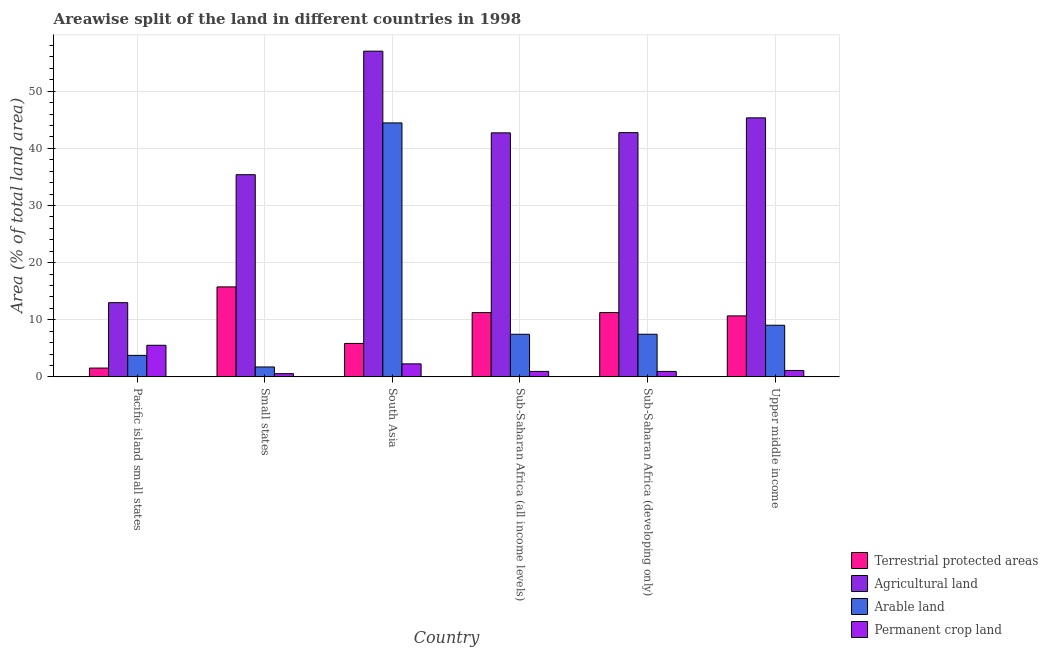How many different coloured bars are there?
Ensure brevity in your answer.  4. Are the number of bars per tick equal to the number of legend labels?
Your answer should be compact. Yes. Are the number of bars on each tick of the X-axis equal?
Your answer should be very brief. Yes. What is the label of the 1st group of bars from the left?
Make the answer very short. Pacific island small states. In how many cases, is the number of bars for a given country not equal to the number of legend labels?
Make the answer very short. 0. What is the percentage of land under terrestrial protection in Small states?
Your response must be concise. 15.75. Across all countries, what is the maximum percentage of area under agricultural land?
Keep it short and to the point. 57. Across all countries, what is the minimum percentage of area under permanent crop land?
Your response must be concise. 0.56. In which country was the percentage of land under terrestrial protection maximum?
Offer a very short reply. Small states. In which country was the percentage of area under arable land minimum?
Offer a very short reply. Small states. What is the total percentage of area under arable land in the graph?
Your answer should be compact. 73.89. What is the difference between the percentage of land under terrestrial protection in Pacific island small states and that in Sub-Saharan Africa (developing only)?
Provide a succinct answer. -9.71. What is the difference between the percentage of area under arable land in Sub-Saharan Africa (all income levels) and the percentage of area under agricultural land in Pacific island small states?
Provide a short and direct response. -5.53. What is the average percentage of area under permanent crop land per country?
Your response must be concise. 1.9. What is the difference between the percentage of area under arable land and percentage of land under terrestrial protection in Small states?
Ensure brevity in your answer.  -14.01. In how many countries, is the percentage of area under arable land greater than 2 %?
Provide a short and direct response. 5. What is the ratio of the percentage of land under terrestrial protection in Pacific island small states to that in Small states?
Provide a succinct answer. 0.1. Is the percentage of land under terrestrial protection in South Asia less than that in Upper middle income?
Offer a very short reply. Yes. Is the difference between the percentage of area under arable land in South Asia and Sub-Saharan Africa (developing only) greater than the difference between the percentage of land under terrestrial protection in South Asia and Sub-Saharan Africa (developing only)?
Make the answer very short. Yes. What is the difference between the highest and the second highest percentage of land under terrestrial protection?
Provide a short and direct response. 4.49. What is the difference between the highest and the lowest percentage of area under permanent crop land?
Make the answer very short. 4.97. In how many countries, is the percentage of area under arable land greater than the average percentage of area under arable land taken over all countries?
Your answer should be very brief. 1. What does the 4th bar from the left in South Asia represents?
Your answer should be compact. Permanent crop land. What does the 4th bar from the right in Sub-Saharan Africa (all income levels) represents?
Provide a short and direct response. Terrestrial protected areas. How many bars are there?
Give a very brief answer. 24. What is the difference between two consecutive major ticks on the Y-axis?
Give a very brief answer. 10. Are the values on the major ticks of Y-axis written in scientific E-notation?
Offer a very short reply. No. Where does the legend appear in the graph?
Keep it short and to the point. Bottom right. How many legend labels are there?
Your answer should be compact. 4. What is the title of the graph?
Keep it short and to the point. Areawise split of the land in different countries in 1998. Does "Primary education" appear as one of the legend labels in the graph?
Your response must be concise. No. What is the label or title of the X-axis?
Your response must be concise. Country. What is the label or title of the Y-axis?
Keep it short and to the point. Area (% of total land area). What is the Area (% of total land area) in Terrestrial protected areas in Pacific island small states?
Give a very brief answer. 1.54. What is the Area (% of total land area) of Agricultural land in Pacific island small states?
Ensure brevity in your answer.  12.99. What is the Area (% of total land area) in Arable land in Pacific island small states?
Make the answer very short. 3.76. What is the Area (% of total land area) of Permanent crop land in Pacific island small states?
Keep it short and to the point. 5.53. What is the Area (% of total land area) in Terrestrial protected areas in Small states?
Ensure brevity in your answer.  15.75. What is the Area (% of total land area) of Agricultural land in Small states?
Provide a short and direct response. 35.38. What is the Area (% of total land area) of Arable land in Small states?
Your answer should be very brief. 1.73. What is the Area (% of total land area) of Permanent crop land in Small states?
Ensure brevity in your answer.  0.56. What is the Area (% of total land area) in Terrestrial protected areas in South Asia?
Provide a short and direct response. 5.85. What is the Area (% of total land area) of Agricultural land in South Asia?
Keep it short and to the point. 57. What is the Area (% of total land area) of Arable land in South Asia?
Keep it short and to the point. 44.45. What is the Area (% of total land area) of Permanent crop land in South Asia?
Your answer should be compact. 2.28. What is the Area (% of total land area) in Terrestrial protected areas in Sub-Saharan Africa (all income levels)?
Offer a very short reply. 11.25. What is the Area (% of total land area) in Agricultural land in Sub-Saharan Africa (all income levels)?
Your response must be concise. 42.71. What is the Area (% of total land area) in Arable land in Sub-Saharan Africa (all income levels)?
Your response must be concise. 7.46. What is the Area (% of total land area) of Permanent crop land in Sub-Saharan Africa (all income levels)?
Ensure brevity in your answer.  0.95. What is the Area (% of total land area) in Terrestrial protected areas in Sub-Saharan Africa (developing only)?
Provide a short and direct response. 11.26. What is the Area (% of total land area) of Agricultural land in Sub-Saharan Africa (developing only)?
Provide a succinct answer. 42.74. What is the Area (% of total land area) in Arable land in Sub-Saharan Africa (developing only)?
Your answer should be compact. 7.46. What is the Area (% of total land area) of Permanent crop land in Sub-Saharan Africa (developing only)?
Provide a succinct answer. 0.95. What is the Area (% of total land area) in Terrestrial protected areas in Upper middle income?
Give a very brief answer. 10.67. What is the Area (% of total land area) in Agricultural land in Upper middle income?
Your answer should be very brief. 45.33. What is the Area (% of total land area) in Arable land in Upper middle income?
Provide a succinct answer. 9.03. What is the Area (% of total land area) in Permanent crop land in Upper middle income?
Offer a terse response. 1.12. Across all countries, what is the maximum Area (% of total land area) in Terrestrial protected areas?
Offer a very short reply. 15.75. Across all countries, what is the maximum Area (% of total land area) in Agricultural land?
Your answer should be very brief. 57. Across all countries, what is the maximum Area (% of total land area) in Arable land?
Provide a succinct answer. 44.45. Across all countries, what is the maximum Area (% of total land area) in Permanent crop land?
Provide a short and direct response. 5.53. Across all countries, what is the minimum Area (% of total land area) of Terrestrial protected areas?
Give a very brief answer. 1.54. Across all countries, what is the minimum Area (% of total land area) of Agricultural land?
Ensure brevity in your answer.  12.99. Across all countries, what is the minimum Area (% of total land area) of Arable land?
Your answer should be very brief. 1.73. Across all countries, what is the minimum Area (% of total land area) in Permanent crop land?
Provide a succinct answer. 0.56. What is the total Area (% of total land area) of Terrestrial protected areas in the graph?
Provide a short and direct response. 56.32. What is the total Area (% of total land area) of Agricultural land in the graph?
Keep it short and to the point. 236.16. What is the total Area (% of total land area) in Arable land in the graph?
Your response must be concise. 73.89. What is the total Area (% of total land area) in Permanent crop land in the graph?
Your response must be concise. 11.4. What is the difference between the Area (% of total land area) in Terrestrial protected areas in Pacific island small states and that in Small states?
Provide a short and direct response. -14.21. What is the difference between the Area (% of total land area) in Agricultural land in Pacific island small states and that in Small states?
Make the answer very short. -22.4. What is the difference between the Area (% of total land area) of Arable land in Pacific island small states and that in Small states?
Your response must be concise. 2.03. What is the difference between the Area (% of total land area) in Permanent crop land in Pacific island small states and that in Small states?
Ensure brevity in your answer.  4.97. What is the difference between the Area (% of total land area) in Terrestrial protected areas in Pacific island small states and that in South Asia?
Your answer should be very brief. -4.31. What is the difference between the Area (% of total land area) of Agricultural land in Pacific island small states and that in South Asia?
Make the answer very short. -44.02. What is the difference between the Area (% of total land area) of Arable land in Pacific island small states and that in South Asia?
Offer a terse response. -40.68. What is the difference between the Area (% of total land area) of Permanent crop land in Pacific island small states and that in South Asia?
Your answer should be compact. 3.26. What is the difference between the Area (% of total land area) of Terrestrial protected areas in Pacific island small states and that in Sub-Saharan Africa (all income levels)?
Make the answer very short. -9.71. What is the difference between the Area (% of total land area) of Agricultural land in Pacific island small states and that in Sub-Saharan Africa (all income levels)?
Ensure brevity in your answer.  -29.72. What is the difference between the Area (% of total land area) in Arable land in Pacific island small states and that in Sub-Saharan Africa (all income levels)?
Keep it short and to the point. -3.69. What is the difference between the Area (% of total land area) of Permanent crop land in Pacific island small states and that in Sub-Saharan Africa (all income levels)?
Provide a short and direct response. 4.58. What is the difference between the Area (% of total land area) in Terrestrial protected areas in Pacific island small states and that in Sub-Saharan Africa (developing only)?
Provide a succinct answer. -9.71. What is the difference between the Area (% of total land area) in Agricultural land in Pacific island small states and that in Sub-Saharan Africa (developing only)?
Your response must be concise. -29.76. What is the difference between the Area (% of total land area) in Arable land in Pacific island small states and that in Sub-Saharan Africa (developing only)?
Your response must be concise. -3.69. What is the difference between the Area (% of total land area) of Permanent crop land in Pacific island small states and that in Sub-Saharan Africa (developing only)?
Ensure brevity in your answer.  4.58. What is the difference between the Area (% of total land area) in Terrestrial protected areas in Pacific island small states and that in Upper middle income?
Your response must be concise. -9.13. What is the difference between the Area (% of total land area) of Agricultural land in Pacific island small states and that in Upper middle income?
Make the answer very short. -32.34. What is the difference between the Area (% of total land area) in Arable land in Pacific island small states and that in Upper middle income?
Ensure brevity in your answer.  -5.27. What is the difference between the Area (% of total land area) of Permanent crop land in Pacific island small states and that in Upper middle income?
Your answer should be very brief. 4.41. What is the difference between the Area (% of total land area) of Terrestrial protected areas in Small states and that in South Asia?
Your response must be concise. 9.9. What is the difference between the Area (% of total land area) of Agricultural land in Small states and that in South Asia?
Provide a short and direct response. -21.62. What is the difference between the Area (% of total land area) in Arable land in Small states and that in South Asia?
Make the answer very short. -42.71. What is the difference between the Area (% of total land area) of Permanent crop land in Small states and that in South Asia?
Your answer should be compact. -1.72. What is the difference between the Area (% of total land area) in Terrestrial protected areas in Small states and that in Sub-Saharan Africa (all income levels)?
Offer a terse response. 4.5. What is the difference between the Area (% of total land area) of Agricultural land in Small states and that in Sub-Saharan Africa (all income levels)?
Ensure brevity in your answer.  -7.32. What is the difference between the Area (% of total land area) in Arable land in Small states and that in Sub-Saharan Africa (all income levels)?
Give a very brief answer. -5.72. What is the difference between the Area (% of total land area) in Permanent crop land in Small states and that in Sub-Saharan Africa (all income levels)?
Give a very brief answer. -0.4. What is the difference between the Area (% of total land area) in Terrestrial protected areas in Small states and that in Sub-Saharan Africa (developing only)?
Your answer should be compact. 4.49. What is the difference between the Area (% of total land area) in Agricultural land in Small states and that in Sub-Saharan Africa (developing only)?
Offer a terse response. -7.36. What is the difference between the Area (% of total land area) in Arable land in Small states and that in Sub-Saharan Africa (developing only)?
Provide a succinct answer. -5.73. What is the difference between the Area (% of total land area) in Permanent crop land in Small states and that in Sub-Saharan Africa (developing only)?
Provide a short and direct response. -0.39. What is the difference between the Area (% of total land area) of Terrestrial protected areas in Small states and that in Upper middle income?
Ensure brevity in your answer.  5.08. What is the difference between the Area (% of total land area) of Agricultural land in Small states and that in Upper middle income?
Provide a short and direct response. -9.95. What is the difference between the Area (% of total land area) of Arable land in Small states and that in Upper middle income?
Your answer should be compact. -7.3. What is the difference between the Area (% of total land area) of Permanent crop land in Small states and that in Upper middle income?
Your answer should be very brief. -0.56. What is the difference between the Area (% of total land area) of Agricultural land in South Asia and that in Sub-Saharan Africa (all income levels)?
Give a very brief answer. 14.3. What is the difference between the Area (% of total land area) of Arable land in South Asia and that in Sub-Saharan Africa (all income levels)?
Provide a short and direct response. 36.99. What is the difference between the Area (% of total land area) of Permanent crop land in South Asia and that in Sub-Saharan Africa (all income levels)?
Keep it short and to the point. 1.32. What is the difference between the Area (% of total land area) in Terrestrial protected areas in South Asia and that in Sub-Saharan Africa (developing only)?
Ensure brevity in your answer.  -5.4. What is the difference between the Area (% of total land area) in Agricultural land in South Asia and that in Sub-Saharan Africa (developing only)?
Ensure brevity in your answer.  14.26. What is the difference between the Area (% of total land area) of Arable land in South Asia and that in Sub-Saharan Africa (developing only)?
Your answer should be compact. 36.99. What is the difference between the Area (% of total land area) of Permanent crop land in South Asia and that in Sub-Saharan Africa (developing only)?
Ensure brevity in your answer.  1.32. What is the difference between the Area (% of total land area) of Terrestrial protected areas in South Asia and that in Upper middle income?
Ensure brevity in your answer.  -4.82. What is the difference between the Area (% of total land area) in Agricultural land in South Asia and that in Upper middle income?
Your response must be concise. 11.67. What is the difference between the Area (% of total land area) of Arable land in South Asia and that in Upper middle income?
Keep it short and to the point. 35.41. What is the difference between the Area (% of total land area) of Permanent crop land in South Asia and that in Upper middle income?
Give a very brief answer. 1.15. What is the difference between the Area (% of total land area) of Terrestrial protected areas in Sub-Saharan Africa (all income levels) and that in Sub-Saharan Africa (developing only)?
Give a very brief answer. -0. What is the difference between the Area (% of total land area) of Agricultural land in Sub-Saharan Africa (all income levels) and that in Sub-Saharan Africa (developing only)?
Your answer should be very brief. -0.04. What is the difference between the Area (% of total land area) in Arable land in Sub-Saharan Africa (all income levels) and that in Sub-Saharan Africa (developing only)?
Offer a very short reply. -0. What is the difference between the Area (% of total land area) of Permanent crop land in Sub-Saharan Africa (all income levels) and that in Sub-Saharan Africa (developing only)?
Your answer should be very brief. 0. What is the difference between the Area (% of total land area) in Terrestrial protected areas in Sub-Saharan Africa (all income levels) and that in Upper middle income?
Keep it short and to the point. 0.58. What is the difference between the Area (% of total land area) in Agricultural land in Sub-Saharan Africa (all income levels) and that in Upper middle income?
Keep it short and to the point. -2.62. What is the difference between the Area (% of total land area) of Arable land in Sub-Saharan Africa (all income levels) and that in Upper middle income?
Offer a very short reply. -1.58. What is the difference between the Area (% of total land area) of Permanent crop land in Sub-Saharan Africa (all income levels) and that in Upper middle income?
Give a very brief answer. -0.17. What is the difference between the Area (% of total land area) in Terrestrial protected areas in Sub-Saharan Africa (developing only) and that in Upper middle income?
Make the answer very short. 0.59. What is the difference between the Area (% of total land area) in Agricultural land in Sub-Saharan Africa (developing only) and that in Upper middle income?
Your answer should be very brief. -2.59. What is the difference between the Area (% of total land area) in Arable land in Sub-Saharan Africa (developing only) and that in Upper middle income?
Make the answer very short. -1.58. What is the difference between the Area (% of total land area) in Permanent crop land in Sub-Saharan Africa (developing only) and that in Upper middle income?
Offer a terse response. -0.17. What is the difference between the Area (% of total land area) of Terrestrial protected areas in Pacific island small states and the Area (% of total land area) of Agricultural land in Small states?
Your answer should be compact. -33.84. What is the difference between the Area (% of total land area) in Terrestrial protected areas in Pacific island small states and the Area (% of total land area) in Arable land in Small states?
Keep it short and to the point. -0.19. What is the difference between the Area (% of total land area) of Terrestrial protected areas in Pacific island small states and the Area (% of total land area) of Permanent crop land in Small states?
Provide a succinct answer. 0.98. What is the difference between the Area (% of total land area) in Agricultural land in Pacific island small states and the Area (% of total land area) in Arable land in Small states?
Offer a terse response. 11.25. What is the difference between the Area (% of total land area) of Agricultural land in Pacific island small states and the Area (% of total land area) of Permanent crop land in Small states?
Your answer should be very brief. 12.43. What is the difference between the Area (% of total land area) of Arable land in Pacific island small states and the Area (% of total land area) of Permanent crop land in Small states?
Your answer should be compact. 3.2. What is the difference between the Area (% of total land area) in Terrestrial protected areas in Pacific island small states and the Area (% of total land area) in Agricultural land in South Asia?
Ensure brevity in your answer.  -55.46. What is the difference between the Area (% of total land area) in Terrestrial protected areas in Pacific island small states and the Area (% of total land area) in Arable land in South Asia?
Give a very brief answer. -42.9. What is the difference between the Area (% of total land area) of Terrestrial protected areas in Pacific island small states and the Area (% of total land area) of Permanent crop land in South Asia?
Keep it short and to the point. -0.73. What is the difference between the Area (% of total land area) in Agricultural land in Pacific island small states and the Area (% of total land area) in Arable land in South Asia?
Your answer should be very brief. -31.46. What is the difference between the Area (% of total land area) in Agricultural land in Pacific island small states and the Area (% of total land area) in Permanent crop land in South Asia?
Ensure brevity in your answer.  10.71. What is the difference between the Area (% of total land area) in Arable land in Pacific island small states and the Area (% of total land area) in Permanent crop land in South Asia?
Keep it short and to the point. 1.49. What is the difference between the Area (% of total land area) of Terrestrial protected areas in Pacific island small states and the Area (% of total land area) of Agricultural land in Sub-Saharan Africa (all income levels)?
Your answer should be very brief. -41.17. What is the difference between the Area (% of total land area) in Terrestrial protected areas in Pacific island small states and the Area (% of total land area) in Arable land in Sub-Saharan Africa (all income levels)?
Make the answer very short. -5.91. What is the difference between the Area (% of total land area) of Terrestrial protected areas in Pacific island small states and the Area (% of total land area) of Permanent crop land in Sub-Saharan Africa (all income levels)?
Your response must be concise. 0.59. What is the difference between the Area (% of total land area) of Agricultural land in Pacific island small states and the Area (% of total land area) of Arable land in Sub-Saharan Africa (all income levels)?
Provide a short and direct response. 5.53. What is the difference between the Area (% of total land area) of Agricultural land in Pacific island small states and the Area (% of total land area) of Permanent crop land in Sub-Saharan Africa (all income levels)?
Your answer should be very brief. 12.03. What is the difference between the Area (% of total land area) of Arable land in Pacific island small states and the Area (% of total land area) of Permanent crop land in Sub-Saharan Africa (all income levels)?
Ensure brevity in your answer.  2.81. What is the difference between the Area (% of total land area) in Terrestrial protected areas in Pacific island small states and the Area (% of total land area) in Agricultural land in Sub-Saharan Africa (developing only)?
Offer a very short reply. -41.2. What is the difference between the Area (% of total land area) of Terrestrial protected areas in Pacific island small states and the Area (% of total land area) of Arable land in Sub-Saharan Africa (developing only)?
Offer a very short reply. -5.92. What is the difference between the Area (% of total land area) in Terrestrial protected areas in Pacific island small states and the Area (% of total land area) in Permanent crop land in Sub-Saharan Africa (developing only)?
Provide a succinct answer. 0.59. What is the difference between the Area (% of total land area) in Agricultural land in Pacific island small states and the Area (% of total land area) in Arable land in Sub-Saharan Africa (developing only)?
Keep it short and to the point. 5.53. What is the difference between the Area (% of total land area) of Agricultural land in Pacific island small states and the Area (% of total land area) of Permanent crop land in Sub-Saharan Africa (developing only)?
Your response must be concise. 12.04. What is the difference between the Area (% of total land area) of Arable land in Pacific island small states and the Area (% of total land area) of Permanent crop land in Sub-Saharan Africa (developing only)?
Give a very brief answer. 2.81. What is the difference between the Area (% of total land area) of Terrestrial protected areas in Pacific island small states and the Area (% of total land area) of Agricultural land in Upper middle income?
Ensure brevity in your answer.  -43.79. What is the difference between the Area (% of total land area) of Terrestrial protected areas in Pacific island small states and the Area (% of total land area) of Arable land in Upper middle income?
Your response must be concise. -7.49. What is the difference between the Area (% of total land area) in Terrestrial protected areas in Pacific island small states and the Area (% of total land area) in Permanent crop land in Upper middle income?
Keep it short and to the point. 0.42. What is the difference between the Area (% of total land area) of Agricultural land in Pacific island small states and the Area (% of total land area) of Arable land in Upper middle income?
Offer a very short reply. 3.95. What is the difference between the Area (% of total land area) of Agricultural land in Pacific island small states and the Area (% of total land area) of Permanent crop land in Upper middle income?
Your answer should be compact. 11.86. What is the difference between the Area (% of total land area) in Arable land in Pacific island small states and the Area (% of total land area) in Permanent crop land in Upper middle income?
Offer a terse response. 2.64. What is the difference between the Area (% of total land area) of Terrestrial protected areas in Small states and the Area (% of total land area) of Agricultural land in South Asia?
Provide a succinct answer. -41.26. What is the difference between the Area (% of total land area) of Terrestrial protected areas in Small states and the Area (% of total land area) of Arable land in South Asia?
Ensure brevity in your answer.  -28.7. What is the difference between the Area (% of total land area) in Terrestrial protected areas in Small states and the Area (% of total land area) in Permanent crop land in South Asia?
Make the answer very short. 13.47. What is the difference between the Area (% of total land area) of Agricultural land in Small states and the Area (% of total land area) of Arable land in South Asia?
Offer a terse response. -9.06. What is the difference between the Area (% of total land area) in Agricultural land in Small states and the Area (% of total land area) in Permanent crop land in South Asia?
Ensure brevity in your answer.  33.11. What is the difference between the Area (% of total land area) of Arable land in Small states and the Area (% of total land area) of Permanent crop land in South Asia?
Your answer should be compact. -0.54. What is the difference between the Area (% of total land area) in Terrestrial protected areas in Small states and the Area (% of total land area) in Agricultural land in Sub-Saharan Africa (all income levels)?
Provide a short and direct response. -26.96. What is the difference between the Area (% of total land area) of Terrestrial protected areas in Small states and the Area (% of total land area) of Arable land in Sub-Saharan Africa (all income levels)?
Offer a terse response. 8.29. What is the difference between the Area (% of total land area) of Terrestrial protected areas in Small states and the Area (% of total land area) of Permanent crop land in Sub-Saharan Africa (all income levels)?
Ensure brevity in your answer.  14.79. What is the difference between the Area (% of total land area) of Agricultural land in Small states and the Area (% of total land area) of Arable land in Sub-Saharan Africa (all income levels)?
Provide a short and direct response. 27.93. What is the difference between the Area (% of total land area) of Agricultural land in Small states and the Area (% of total land area) of Permanent crop land in Sub-Saharan Africa (all income levels)?
Your answer should be compact. 34.43. What is the difference between the Area (% of total land area) in Arable land in Small states and the Area (% of total land area) in Permanent crop land in Sub-Saharan Africa (all income levels)?
Your answer should be compact. 0.78. What is the difference between the Area (% of total land area) of Terrestrial protected areas in Small states and the Area (% of total land area) of Agricultural land in Sub-Saharan Africa (developing only)?
Give a very brief answer. -27. What is the difference between the Area (% of total land area) of Terrestrial protected areas in Small states and the Area (% of total land area) of Arable land in Sub-Saharan Africa (developing only)?
Offer a very short reply. 8.29. What is the difference between the Area (% of total land area) in Terrestrial protected areas in Small states and the Area (% of total land area) in Permanent crop land in Sub-Saharan Africa (developing only)?
Provide a short and direct response. 14.8. What is the difference between the Area (% of total land area) of Agricultural land in Small states and the Area (% of total land area) of Arable land in Sub-Saharan Africa (developing only)?
Offer a very short reply. 27.92. What is the difference between the Area (% of total land area) of Agricultural land in Small states and the Area (% of total land area) of Permanent crop land in Sub-Saharan Africa (developing only)?
Provide a short and direct response. 34.43. What is the difference between the Area (% of total land area) of Arable land in Small states and the Area (% of total land area) of Permanent crop land in Sub-Saharan Africa (developing only)?
Offer a very short reply. 0.78. What is the difference between the Area (% of total land area) of Terrestrial protected areas in Small states and the Area (% of total land area) of Agricultural land in Upper middle income?
Offer a very short reply. -29.58. What is the difference between the Area (% of total land area) of Terrestrial protected areas in Small states and the Area (% of total land area) of Arable land in Upper middle income?
Your answer should be very brief. 6.71. What is the difference between the Area (% of total land area) of Terrestrial protected areas in Small states and the Area (% of total land area) of Permanent crop land in Upper middle income?
Offer a very short reply. 14.62. What is the difference between the Area (% of total land area) of Agricultural land in Small states and the Area (% of total land area) of Arable land in Upper middle income?
Provide a short and direct response. 26.35. What is the difference between the Area (% of total land area) of Agricultural land in Small states and the Area (% of total land area) of Permanent crop land in Upper middle income?
Ensure brevity in your answer.  34.26. What is the difference between the Area (% of total land area) of Arable land in Small states and the Area (% of total land area) of Permanent crop land in Upper middle income?
Make the answer very short. 0.61. What is the difference between the Area (% of total land area) in Terrestrial protected areas in South Asia and the Area (% of total land area) in Agricultural land in Sub-Saharan Africa (all income levels)?
Your response must be concise. -36.85. What is the difference between the Area (% of total land area) of Terrestrial protected areas in South Asia and the Area (% of total land area) of Arable land in Sub-Saharan Africa (all income levels)?
Provide a succinct answer. -1.6. What is the difference between the Area (% of total land area) in Terrestrial protected areas in South Asia and the Area (% of total land area) in Permanent crop land in Sub-Saharan Africa (all income levels)?
Offer a very short reply. 4.9. What is the difference between the Area (% of total land area) of Agricultural land in South Asia and the Area (% of total land area) of Arable land in Sub-Saharan Africa (all income levels)?
Your response must be concise. 49.55. What is the difference between the Area (% of total land area) in Agricultural land in South Asia and the Area (% of total land area) in Permanent crop land in Sub-Saharan Africa (all income levels)?
Your answer should be very brief. 56.05. What is the difference between the Area (% of total land area) in Arable land in South Asia and the Area (% of total land area) in Permanent crop land in Sub-Saharan Africa (all income levels)?
Ensure brevity in your answer.  43.49. What is the difference between the Area (% of total land area) in Terrestrial protected areas in South Asia and the Area (% of total land area) in Agricultural land in Sub-Saharan Africa (developing only)?
Your response must be concise. -36.89. What is the difference between the Area (% of total land area) in Terrestrial protected areas in South Asia and the Area (% of total land area) in Arable land in Sub-Saharan Africa (developing only)?
Keep it short and to the point. -1.61. What is the difference between the Area (% of total land area) of Terrestrial protected areas in South Asia and the Area (% of total land area) of Permanent crop land in Sub-Saharan Africa (developing only)?
Your answer should be compact. 4.9. What is the difference between the Area (% of total land area) in Agricultural land in South Asia and the Area (% of total land area) in Arable land in Sub-Saharan Africa (developing only)?
Offer a very short reply. 49.54. What is the difference between the Area (% of total land area) in Agricultural land in South Asia and the Area (% of total land area) in Permanent crop land in Sub-Saharan Africa (developing only)?
Offer a very short reply. 56.05. What is the difference between the Area (% of total land area) of Arable land in South Asia and the Area (% of total land area) of Permanent crop land in Sub-Saharan Africa (developing only)?
Keep it short and to the point. 43.49. What is the difference between the Area (% of total land area) of Terrestrial protected areas in South Asia and the Area (% of total land area) of Agricultural land in Upper middle income?
Your response must be concise. -39.48. What is the difference between the Area (% of total land area) of Terrestrial protected areas in South Asia and the Area (% of total land area) of Arable land in Upper middle income?
Offer a very short reply. -3.18. What is the difference between the Area (% of total land area) in Terrestrial protected areas in South Asia and the Area (% of total land area) in Permanent crop land in Upper middle income?
Give a very brief answer. 4.73. What is the difference between the Area (% of total land area) of Agricultural land in South Asia and the Area (% of total land area) of Arable land in Upper middle income?
Provide a short and direct response. 47.97. What is the difference between the Area (% of total land area) in Agricultural land in South Asia and the Area (% of total land area) in Permanent crop land in Upper middle income?
Give a very brief answer. 55.88. What is the difference between the Area (% of total land area) of Arable land in South Asia and the Area (% of total land area) of Permanent crop land in Upper middle income?
Keep it short and to the point. 43.32. What is the difference between the Area (% of total land area) of Terrestrial protected areas in Sub-Saharan Africa (all income levels) and the Area (% of total land area) of Agricultural land in Sub-Saharan Africa (developing only)?
Offer a terse response. -31.49. What is the difference between the Area (% of total land area) in Terrestrial protected areas in Sub-Saharan Africa (all income levels) and the Area (% of total land area) in Arable land in Sub-Saharan Africa (developing only)?
Make the answer very short. 3.79. What is the difference between the Area (% of total land area) of Terrestrial protected areas in Sub-Saharan Africa (all income levels) and the Area (% of total land area) of Permanent crop land in Sub-Saharan Africa (developing only)?
Your answer should be compact. 10.3. What is the difference between the Area (% of total land area) in Agricultural land in Sub-Saharan Africa (all income levels) and the Area (% of total land area) in Arable land in Sub-Saharan Africa (developing only)?
Provide a succinct answer. 35.25. What is the difference between the Area (% of total land area) in Agricultural land in Sub-Saharan Africa (all income levels) and the Area (% of total land area) in Permanent crop land in Sub-Saharan Africa (developing only)?
Offer a very short reply. 41.76. What is the difference between the Area (% of total land area) of Arable land in Sub-Saharan Africa (all income levels) and the Area (% of total land area) of Permanent crop land in Sub-Saharan Africa (developing only)?
Your response must be concise. 6.5. What is the difference between the Area (% of total land area) in Terrestrial protected areas in Sub-Saharan Africa (all income levels) and the Area (% of total land area) in Agricultural land in Upper middle income?
Provide a succinct answer. -34.08. What is the difference between the Area (% of total land area) in Terrestrial protected areas in Sub-Saharan Africa (all income levels) and the Area (% of total land area) in Arable land in Upper middle income?
Your answer should be very brief. 2.22. What is the difference between the Area (% of total land area) of Terrestrial protected areas in Sub-Saharan Africa (all income levels) and the Area (% of total land area) of Permanent crop land in Upper middle income?
Give a very brief answer. 10.13. What is the difference between the Area (% of total land area) in Agricultural land in Sub-Saharan Africa (all income levels) and the Area (% of total land area) in Arable land in Upper middle income?
Your answer should be very brief. 33.67. What is the difference between the Area (% of total land area) of Agricultural land in Sub-Saharan Africa (all income levels) and the Area (% of total land area) of Permanent crop land in Upper middle income?
Give a very brief answer. 41.58. What is the difference between the Area (% of total land area) of Arable land in Sub-Saharan Africa (all income levels) and the Area (% of total land area) of Permanent crop land in Upper middle income?
Your response must be concise. 6.33. What is the difference between the Area (% of total land area) in Terrestrial protected areas in Sub-Saharan Africa (developing only) and the Area (% of total land area) in Agricultural land in Upper middle income?
Offer a terse response. -34.07. What is the difference between the Area (% of total land area) of Terrestrial protected areas in Sub-Saharan Africa (developing only) and the Area (% of total land area) of Arable land in Upper middle income?
Your answer should be compact. 2.22. What is the difference between the Area (% of total land area) in Terrestrial protected areas in Sub-Saharan Africa (developing only) and the Area (% of total land area) in Permanent crop land in Upper middle income?
Offer a terse response. 10.13. What is the difference between the Area (% of total land area) in Agricultural land in Sub-Saharan Africa (developing only) and the Area (% of total land area) in Arable land in Upper middle income?
Offer a terse response. 33.71. What is the difference between the Area (% of total land area) of Agricultural land in Sub-Saharan Africa (developing only) and the Area (% of total land area) of Permanent crop land in Upper middle income?
Keep it short and to the point. 41.62. What is the difference between the Area (% of total land area) of Arable land in Sub-Saharan Africa (developing only) and the Area (% of total land area) of Permanent crop land in Upper middle income?
Your answer should be compact. 6.34. What is the average Area (% of total land area) in Terrestrial protected areas per country?
Keep it short and to the point. 9.39. What is the average Area (% of total land area) of Agricultural land per country?
Your response must be concise. 39.36. What is the average Area (% of total land area) of Arable land per country?
Provide a succinct answer. 12.32. What is the average Area (% of total land area) in Permanent crop land per country?
Your answer should be very brief. 1.9. What is the difference between the Area (% of total land area) of Terrestrial protected areas and Area (% of total land area) of Agricultural land in Pacific island small states?
Make the answer very short. -11.45. What is the difference between the Area (% of total land area) in Terrestrial protected areas and Area (% of total land area) in Arable land in Pacific island small states?
Offer a terse response. -2.22. What is the difference between the Area (% of total land area) of Terrestrial protected areas and Area (% of total land area) of Permanent crop land in Pacific island small states?
Offer a terse response. -3.99. What is the difference between the Area (% of total land area) of Agricultural land and Area (% of total land area) of Arable land in Pacific island small states?
Provide a succinct answer. 9.22. What is the difference between the Area (% of total land area) of Agricultural land and Area (% of total land area) of Permanent crop land in Pacific island small states?
Your answer should be compact. 7.46. What is the difference between the Area (% of total land area) of Arable land and Area (% of total land area) of Permanent crop land in Pacific island small states?
Your response must be concise. -1.77. What is the difference between the Area (% of total land area) of Terrestrial protected areas and Area (% of total land area) of Agricultural land in Small states?
Your answer should be compact. -19.64. What is the difference between the Area (% of total land area) of Terrestrial protected areas and Area (% of total land area) of Arable land in Small states?
Offer a very short reply. 14.01. What is the difference between the Area (% of total land area) of Terrestrial protected areas and Area (% of total land area) of Permanent crop land in Small states?
Offer a terse response. 15.19. What is the difference between the Area (% of total land area) of Agricultural land and Area (% of total land area) of Arable land in Small states?
Your answer should be very brief. 33.65. What is the difference between the Area (% of total land area) in Agricultural land and Area (% of total land area) in Permanent crop land in Small states?
Offer a terse response. 34.82. What is the difference between the Area (% of total land area) of Arable land and Area (% of total land area) of Permanent crop land in Small states?
Offer a terse response. 1.17. What is the difference between the Area (% of total land area) of Terrestrial protected areas and Area (% of total land area) of Agricultural land in South Asia?
Make the answer very short. -51.15. What is the difference between the Area (% of total land area) in Terrestrial protected areas and Area (% of total land area) in Arable land in South Asia?
Your answer should be compact. -38.59. What is the difference between the Area (% of total land area) in Terrestrial protected areas and Area (% of total land area) in Permanent crop land in South Asia?
Offer a terse response. 3.58. What is the difference between the Area (% of total land area) of Agricultural land and Area (% of total land area) of Arable land in South Asia?
Make the answer very short. 12.56. What is the difference between the Area (% of total land area) in Agricultural land and Area (% of total land area) in Permanent crop land in South Asia?
Give a very brief answer. 54.73. What is the difference between the Area (% of total land area) of Arable land and Area (% of total land area) of Permanent crop land in South Asia?
Your response must be concise. 42.17. What is the difference between the Area (% of total land area) in Terrestrial protected areas and Area (% of total land area) in Agricultural land in Sub-Saharan Africa (all income levels)?
Provide a succinct answer. -31.45. What is the difference between the Area (% of total land area) of Terrestrial protected areas and Area (% of total land area) of Arable land in Sub-Saharan Africa (all income levels)?
Offer a very short reply. 3.8. What is the difference between the Area (% of total land area) in Terrestrial protected areas and Area (% of total land area) in Permanent crop land in Sub-Saharan Africa (all income levels)?
Provide a succinct answer. 10.3. What is the difference between the Area (% of total land area) of Agricultural land and Area (% of total land area) of Arable land in Sub-Saharan Africa (all income levels)?
Your answer should be very brief. 35.25. What is the difference between the Area (% of total land area) in Agricultural land and Area (% of total land area) in Permanent crop land in Sub-Saharan Africa (all income levels)?
Offer a very short reply. 41.75. What is the difference between the Area (% of total land area) in Arable land and Area (% of total land area) in Permanent crop land in Sub-Saharan Africa (all income levels)?
Your answer should be very brief. 6.5. What is the difference between the Area (% of total land area) in Terrestrial protected areas and Area (% of total land area) in Agricultural land in Sub-Saharan Africa (developing only)?
Ensure brevity in your answer.  -31.49. What is the difference between the Area (% of total land area) of Terrestrial protected areas and Area (% of total land area) of Arable land in Sub-Saharan Africa (developing only)?
Make the answer very short. 3.8. What is the difference between the Area (% of total land area) of Terrestrial protected areas and Area (% of total land area) of Permanent crop land in Sub-Saharan Africa (developing only)?
Offer a terse response. 10.3. What is the difference between the Area (% of total land area) of Agricultural land and Area (% of total land area) of Arable land in Sub-Saharan Africa (developing only)?
Your response must be concise. 35.29. What is the difference between the Area (% of total land area) of Agricultural land and Area (% of total land area) of Permanent crop land in Sub-Saharan Africa (developing only)?
Ensure brevity in your answer.  41.79. What is the difference between the Area (% of total land area) of Arable land and Area (% of total land area) of Permanent crop land in Sub-Saharan Africa (developing only)?
Ensure brevity in your answer.  6.51. What is the difference between the Area (% of total land area) of Terrestrial protected areas and Area (% of total land area) of Agricultural land in Upper middle income?
Your answer should be very brief. -34.66. What is the difference between the Area (% of total land area) in Terrestrial protected areas and Area (% of total land area) in Arable land in Upper middle income?
Provide a succinct answer. 1.63. What is the difference between the Area (% of total land area) of Terrestrial protected areas and Area (% of total land area) of Permanent crop land in Upper middle income?
Your response must be concise. 9.55. What is the difference between the Area (% of total land area) in Agricultural land and Area (% of total land area) in Arable land in Upper middle income?
Keep it short and to the point. 36.3. What is the difference between the Area (% of total land area) of Agricultural land and Area (% of total land area) of Permanent crop land in Upper middle income?
Your answer should be very brief. 44.21. What is the difference between the Area (% of total land area) in Arable land and Area (% of total land area) in Permanent crop land in Upper middle income?
Your answer should be very brief. 7.91. What is the ratio of the Area (% of total land area) in Terrestrial protected areas in Pacific island small states to that in Small states?
Provide a short and direct response. 0.1. What is the ratio of the Area (% of total land area) of Agricultural land in Pacific island small states to that in Small states?
Provide a succinct answer. 0.37. What is the ratio of the Area (% of total land area) in Arable land in Pacific island small states to that in Small states?
Your response must be concise. 2.17. What is the ratio of the Area (% of total land area) in Permanent crop land in Pacific island small states to that in Small states?
Ensure brevity in your answer.  9.88. What is the ratio of the Area (% of total land area) in Terrestrial protected areas in Pacific island small states to that in South Asia?
Keep it short and to the point. 0.26. What is the ratio of the Area (% of total land area) of Agricultural land in Pacific island small states to that in South Asia?
Provide a short and direct response. 0.23. What is the ratio of the Area (% of total land area) in Arable land in Pacific island small states to that in South Asia?
Offer a terse response. 0.08. What is the ratio of the Area (% of total land area) of Permanent crop land in Pacific island small states to that in South Asia?
Ensure brevity in your answer.  2.43. What is the ratio of the Area (% of total land area) of Terrestrial protected areas in Pacific island small states to that in Sub-Saharan Africa (all income levels)?
Provide a succinct answer. 0.14. What is the ratio of the Area (% of total land area) in Agricultural land in Pacific island small states to that in Sub-Saharan Africa (all income levels)?
Ensure brevity in your answer.  0.3. What is the ratio of the Area (% of total land area) of Arable land in Pacific island small states to that in Sub-Saharan Africa (all income levels)?
Give a very brief answer. 0.5. What is the ratio of the Area (% of total land area) of Permanent crop land in Pacific island small states to that in Sub-Saharan Africa (all income levels)?
Your answer should be very brief. 5.79. What is the ratio of the Area (% of total land area) of Terrestrial protected areas in Pacific island small states to that in Sub-Saharan Africa (developing only)?
Provide a succinct answer. 0.14. What is the ratio of the Area (% of total land area) of Agricultural land in Pacific island small states to that in Sub-Saharan Africa (developing only)?
Your answer should be very brief. 0.3. What is the ratio of the Area (% of total land area) in Arable land in Pacific island small states to that in Sub-Saharan Africa (developing only)?
Your answer should be very brief. 0.5. What is the ratio of the Area (% of total land area) of Permanent crop land in Pacific island small states to that in Sub-Saharan Africa (developing only)?
Offer a very short reply. 5.81. What is the ratio of the Area (% of total land area) in Terrestrial protected areas in Pacific island small states to that in Upper middle income?
Your answer should be very brief. 0.14. What is the ratio of the Area (% of total land area) of Agricultural land in Pacific island small states to that in Upper middle income?
Provide a succinct answer. 0.29. What is the ratio of the Area (% of total land area) of Arable land in Pacific island small states to that in Upper middle income?
Offer a very short reply. 0.42. What is the ratio of the Area (% of total land area) of Permanent crop land in Pacific island small states to that in Upper middle income?
Your answer should be compact. 4.93. What is the ratio of the Area (% of total land area) of Terrestrial protected areas in Small states to that in South Asia?
Your answer should be compact. 2.69. What is the ratio of the Area (% of total land area) in Agricultural land in Small states to that in South Asia?
Give a very brief answer. 0.62. What is the ratio of the Area (% of total land area) of Arable land in Small states to that in South Asia?
Make the answer very short. 0.04. What is the ratio of the Area (% of total land area) in Permanent crop land in Small states to that in South Asia?
Give a very brief answer. 0.25. What is the ratio of the Area (% of total land area) in Terrestrial protected areas in Small states to that in Sub-Saharan Africa (all income levels)?
Offer a terse response. 1.4. What is the ratio of the Area (% of total land area) of Agricultural land in Small states to that in Sub-Saharan Africa (all income levels)?
Provide a short and direct response. 0.83. What is the ratio of the Area (% of total land area) in Arable land in Small states to that in Sub-Saharan Africa (all income levels)?
Your answer should be very brief. 0.23. What is the ratio of the Area (% of total land area) in Permanent crop land in Small states to that in Sub-Saharan Africa (all income levels)?
Provide a succinct answer. 0.59. What is the ratio of the Area (% of total land area) of Terrestrial protected areas in Small states to that in Sub-Saharan Africa (developing only)?
Offer a very short reply. 1.4. What is the ratio of the Area (% of total land area) in Agricultural land in Small states to that in Sub-Saharan Africa (developing only)?
Ensure brevity in your answer.  0.83. What is the ratio of the Area (% of total land area) in Arable land in Small states to that in Sub-Saharan Africa (developing only)?
Offer a terse response. 0.23. What is the ratio of the Area (% of total land area) in Permanent crop land in Small states to that in Sub-Saharan Africa (developing only)?
Ensure brevity in your answer.  0.59. What is the ratio of the Area (% of total land area) of Terrestrial protected areas in Small states to that in Upper middle income?
Offer a terse response. 1.48. What is the ratio of the Area (% of total land area) of Agricultural land in Small states to that in Upper middle income?
Offer a terse response. 0.78. What is the ratio of the Area (% of total land area) in Arable land in Small states to that in Upper middle income?
Provide a succinct answer. 0.19. What is the ratio of the Area (% of total land area) of Permanent crop land in Small states to that in Upper middle income?
Your answer should be very brief. 0.5. What is the ratio of the Area (% of total land area) in Terrestrial protected areas in South Asia to that in Sub-Saharan Africa (all income levels)?
Provide a short and direct response. 0.52. What is the ratio of the Area (% of total land area) in Agricultural land in South Asia to that in Sub-Saharan Africa (all income levels)?
Your response must be concise. 1.33. What is the ratio of the Area (% of total land area) in Arable land in South Asia to that in Sub-Saharan Africa (all income levels)?
Your answer should be compact. 5.96. What is the ratio of the Area (% of total land area) in Permanent crop land in South Asia to that in Sub-Saharan Africa (all income levels)?
Give a very brief answer. 2.38. What is the ratio of the Area (% of total land area) of Terrestrial protected areas in South Asia to that in Sub-Saharan Africa (developing only)?
Offer a very short reply. 0.52. What is the ratio of the Area (% of total land area) of Agricultural land in South Asia to that in Sub-Saharan Africa (developing only)?
Offer a very short reply. 1.33. What is the ratio of the Area (% of total land area) of Arable land in South Asia to that in Sub-Saharan Africa (developing only)?
Your answer should be very brief. 5.96. What is the ratio of the Area (% of total land area) of Permanent crop land in South Asia to that in Sub-Saharan Africa (developing only)?
Keep it short and to the point. 2.39. What is the ratio of the Area (% of total land area) in Terrestrial protected areas in South Asia to that in Upper middle income?
Give a very brief answer. 0.55. What is the ratio of the Area (% of total land area) of Agricultural land in South Asia to that in Upper middle income?
Your answer should be very brief. 1.26. What is the ratio of the Area (% of total land area) of Arable land in South Asia to that in Upper middle income?
Ensure brevity in your answer.  4.92. What is the ratio of the Area (% of total land area) of Permanent crop land in South Asia to that in Upper middle income?
Offer a terse response. 2.03. What is the ratio of the Area (% of total land area) in Terrestrial protected areas in Sub-Saharan Africa (all income levels) to that in Sub-Saharan Africa (developing only)?
Ensure brevity in your answer.  1. What is the ratio of the Area (% of total land area) of Terrestrial protected areas in Sub-Saharan Africa (all income levels) to that in Upper middle income?
Your answer should be compact. 1.05. What is the ratio of the Area (% of total land area) of Agricultural land in Sub-Saharan Africa (all income levels) to that in Upper middle income?
Make the answer very short. 0.94. What is the ratio of the Area (% of total land area) in Arable land in Sub-Saharan Africa (all income levels) to that in Upper middle income?
Offer a very short reply. 0.83. What is the ratio of the Area (% of total land area) in Permanent crop land in Sub-Saharan Africa (all income levels) to that in Upper middle income?
Ensure brevity in your answer.  0.85. What is the ratio of the Area (% of total land area) of Terrestrial protected areas in Sub-Saharan Africa (developing only) to that in Upper middle income?
Your response must be concise. 1.05. What is the ratio of the Area (% of total land area) in Agricultural land in Sub-Saharan Africa (developing only) to that in Upper middle income?
Your answer should be compact. 0.94. What is the ratio of the Area (% of total land area) of Arable land in Sub-Saharan Africa (developing only) to that in Upper middle income?
Give a very brief answer. 0.83. What is the ratio of the Area (% of total land area) of Permanent crop land in Sub-Saharan Africa (developing only) to that in Upper middle income?
Give a very brief answer. 0.85. What is the difference between the highest and the second highest Area (% of total land area) in Terrestrial protected areas?
Offer a very short reply. 4.49. What is the difference between the highest and the second highest Area (% of total land area) of Agricultural land?
Keep it short and to the point. 11.67. What is the difference between the highest and the second highest Area (% of total land area) in Arable land?
Make the answer very short. 35.41. What is the difference between the highest and the second highest Area (% of total land area) of Permanent crop land?
Give a very brief answer. 3.26. What is the difference between the highest and the lowest Area (% of total land area) of Terrestrial protected areas?
Make the answer very short. 14.21. What is the difference between the highest and the lowest Area (% of total land area) in Agricultural land?
Provide a succinct answer. 44.02. What is the difference between the highest and the lowest Area (% of total land area) of Arable land?
Offer a terse response. 42.71. What is the difference between the highest and the lowest Area (% of total land area) in Permanent crop land?
Give a very brief answer. 4.97. 